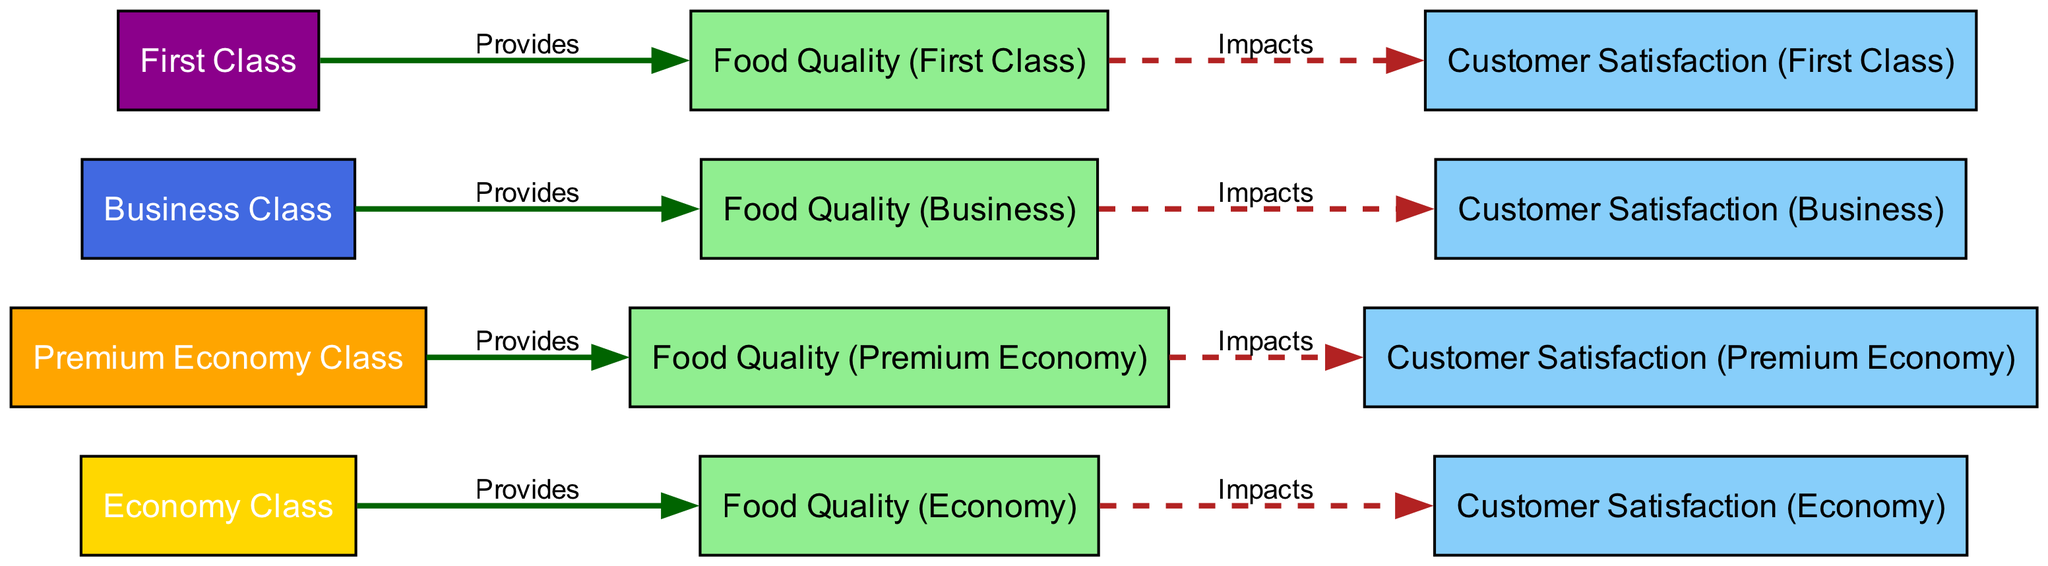What is the color scheme for First Class? The diagram uses a specific color scheme for different airline classes. For First Class, the color is dark magenta (#8B008B), as indicated by the fill color of the node representing First Class.
Answer: dark magenta How many classes provide in-flight food quality? There are four nodes that represent different airline classes: Economy, Premium Economy, Business, and First Class. Each of these classes is connected to a food quality node, indicating they all provide in-flight food quality.
Answer: four Which class has the highest customer satisfaction rating based on the diagram's layout? The diagram shows that the First Class node is linked to its customer satisfaction node, which would typically represent the highest satisfaction level compared to the others given the pattern of food quality impact across classes.
Answer: First Class What type of relationship exists between Business Class and Customer Satisfaction? The relationship is indicated by a dashed line from the food quality node of Business Class to its customer satisfaction node, which represents an impact established based on food quality.
Answer: impacts Which food quality is linked to Economy Class? The Economy Class provides food quality specifically labeled as Food Quality (Economy), which is shown in the diagram connecting the Economy Class node to the relevant food quality node.
Answer: Food Quality (Economy) How many total nodes are present in the diagram? By counting all the nodes represented for the classes, their corresponding food quality, and customer satisfaction, there are twelve nodes in total depicted in the diagram.
Answer: twelve Which class provides the best food quality according to the diagram? Based on the color coding and the nature of links, First Class is generally understood in this context to represent the best food quality as it typically offers the highest standard among airline classes.
Answer: First Class Which class has a dashed line relationship with its food quality? All classes show a dashed line leading from their respective food quality nodes to customer satisfaction nodes, indicating a form of impact. Hence, there is no singular class; all classes share this relationship structure.
Answer: all classes What impact does food quality have on Premium Economy customer satisfaction? The diagram directly connects the food quality of Premium Economy to its customer satisfaction, indicating that food quality here influences the satisfaction level of customers flying in Premium Economy.
Answer: impacts 